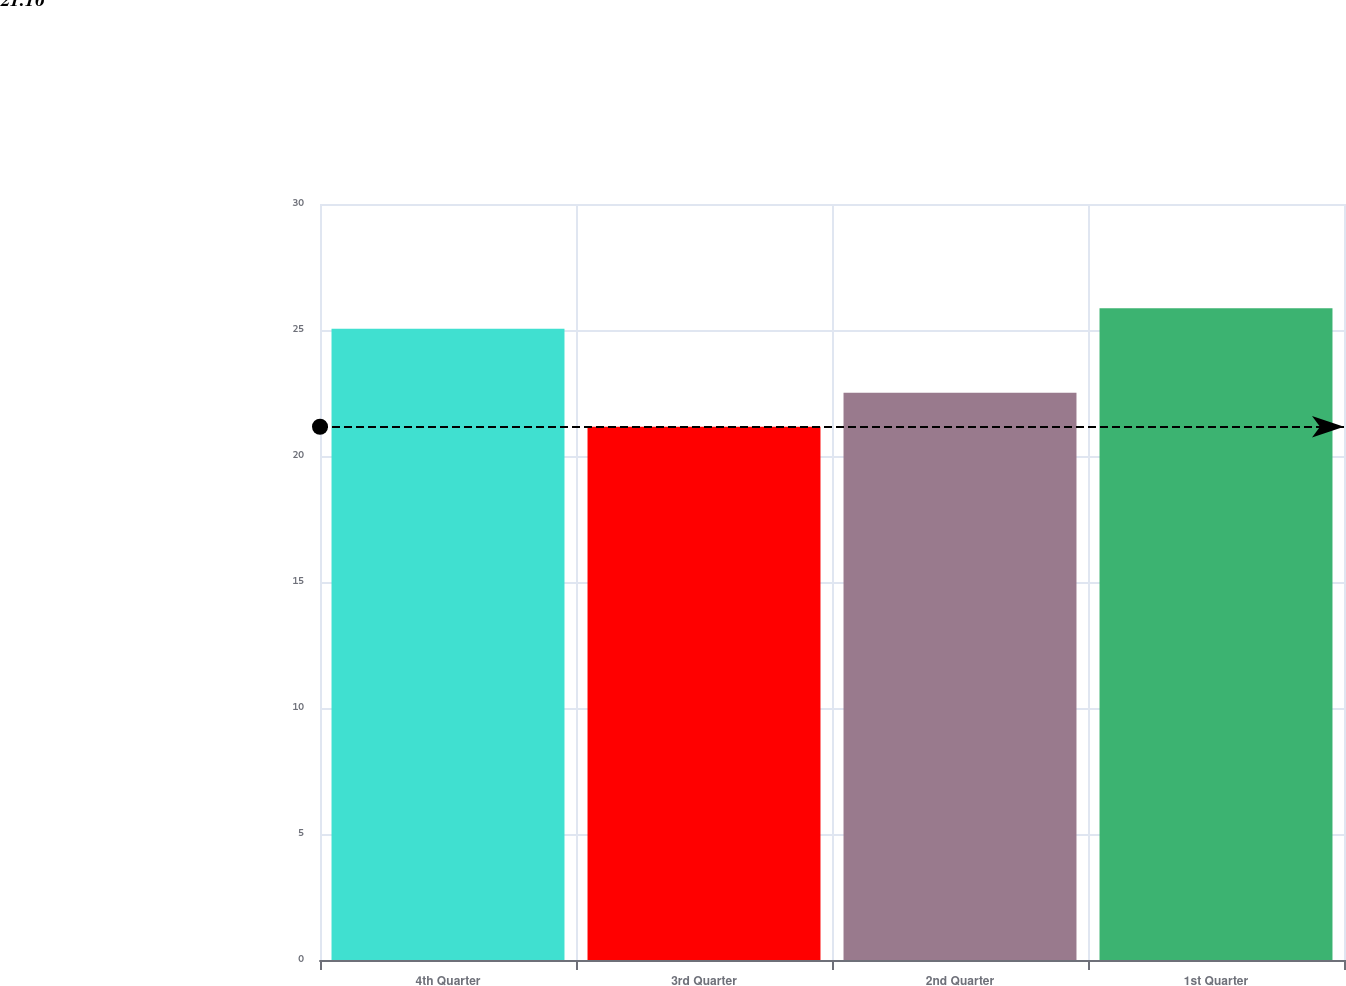Convert chart. <chart><loc_0><loc_0><loc_500><loc_500><bar_chart><fcel>4th Quarter<fcel>3rd Quarter<fcel>2nd Quarter<fcel>1st Quarter<nl><fcel>25.05<fcel>21.16<fcel>22.51<fcel>25.86<nl></chart> 